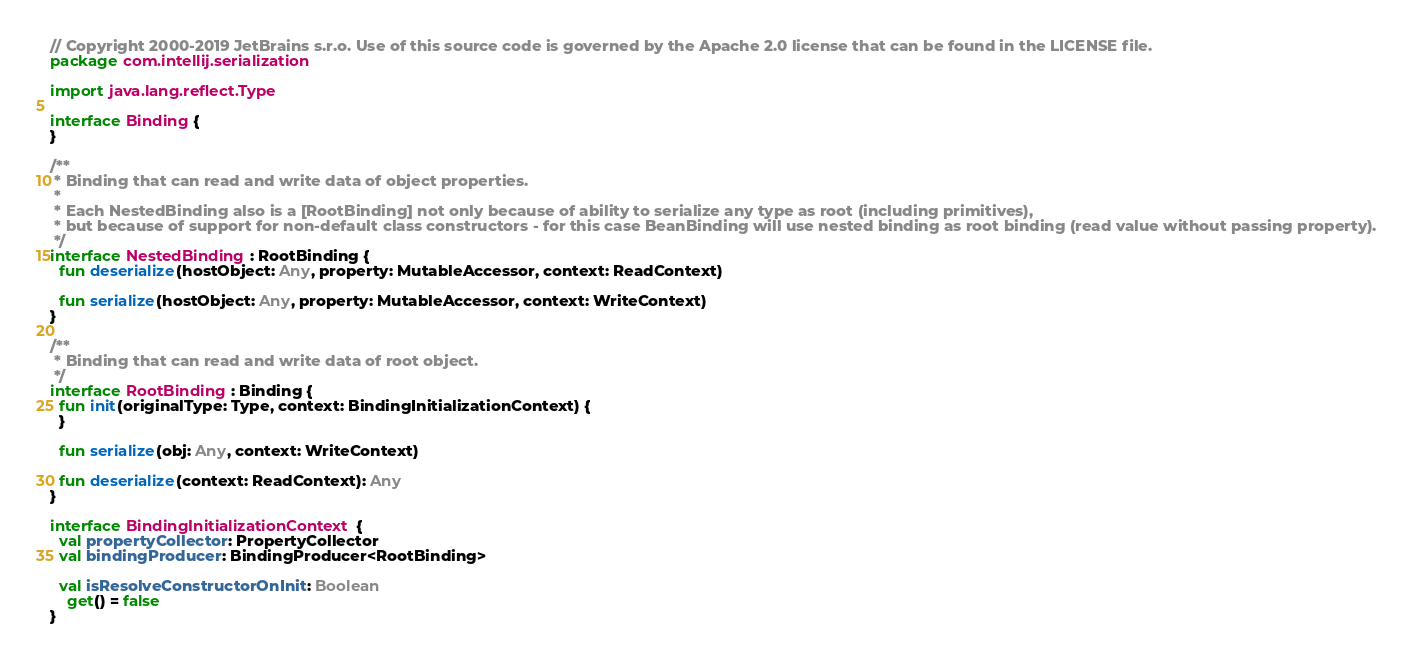<code> <loc_0><loc_0><loc_500><loc_500><_Kotlin_>// Copyright 2000-2019 JetBrains s.r.o. Use of this source code is governed by the Apache 2.0 license that can be found in the LICENSE file.
package com.intellij.serialization

import java.lang.reflect.Type

interface Binding {
}

/**
 * Binding that can read and write data of object properties.
 *
 * Each NestedBinding also is a [RootBinding] not only because of ability to serialize any type as root (including primitives),
 * but because of support for non-default class constructors - for this case BeanBinding will use nested binding as root binding (read value without passing property).
 */
interface NestedBinding : RootBinding {
  fun deserialize(hostObject: Any, property: MutableAccessor, context: ReadContext)

  fun serialize(hostObject: Any, property: MutableAccessor, context: WriteContext)
}

/**
 * Binding that can read and write data of root object.
 */
interface RootBinding : Binding {
  fun init(originalType: Type, context: BindingInitializationContext) {
  }

  fun serialize(obj: Any, context: WriteContext)

  fun deserialize(context: ReadContext): Any
}

interface BindingInitializationContext {
  val propertyCollector: PropertyCollector
  val bindingProducer: BindingProducer<RootBinding>

  val isResolveConstructorOnInit: Boolean
    get() = false
}</code> 